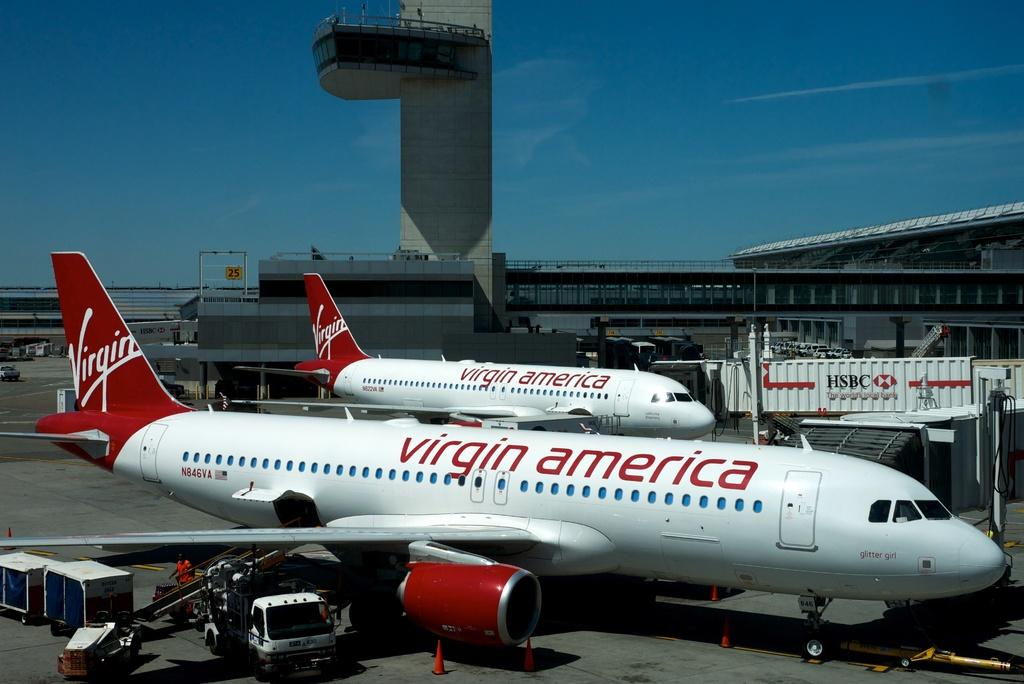<image>
Create a compact narrative representing the image presented. Two red and white Virgin America airplanes at the terminal 